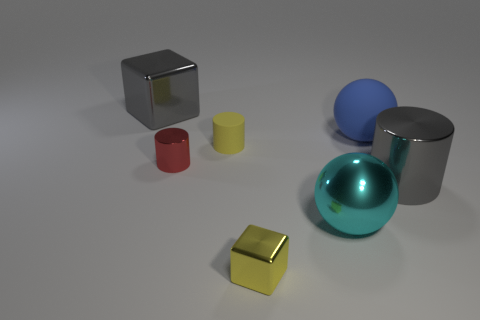How many things are small brown balls or big gray things? In the image, there are no small brown balls. However, there are two big gray items: one is a large gray cylinder and the other appears to be a cube with a darker gray shade. 